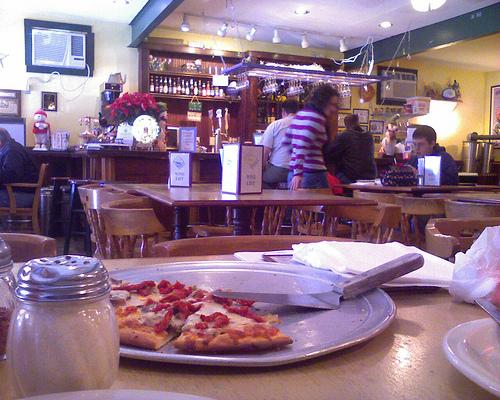What does the tool near the pizza do? serve pizza 